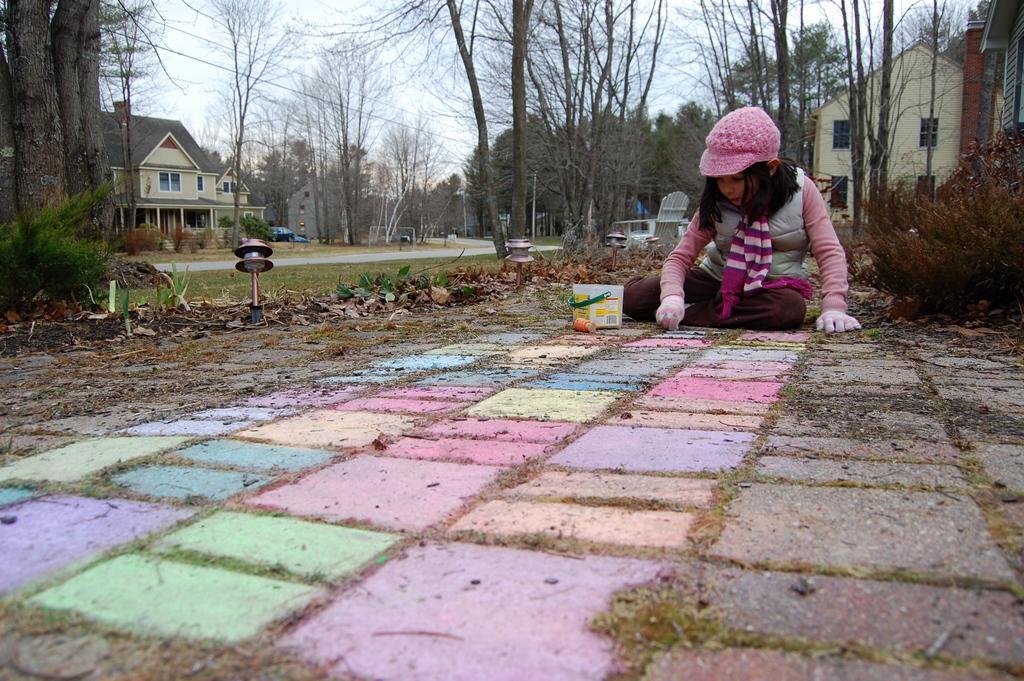In one or two sentences, can you explain what this image depicts? In this image there is a girl sitting on the floor and colouring the blocks which are on the floor. In the background there are beside the road. On the left side there is a building at some distance. At the top there is sky. On the right side there is another building beside the trees. On the floor there is grass and sand. 